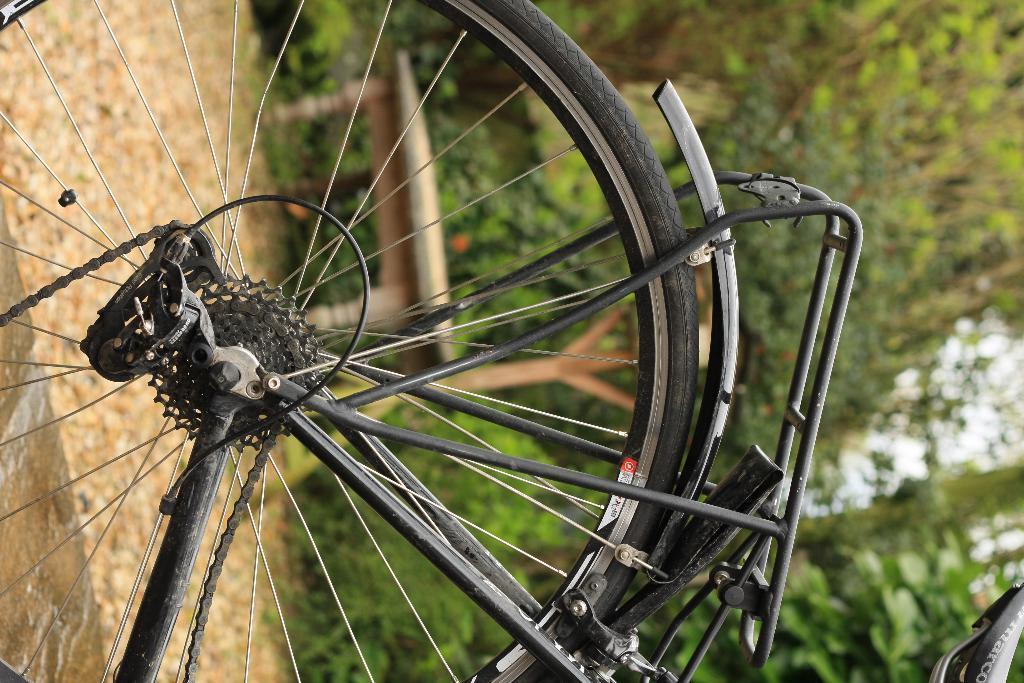How would you summarize this image in a sentence or two? In the picture we can see a bicycle back tire with rim, part of a chain, and on the tire, we can see a carrier and behind the bicycle we can see a table and behind it we can see full of plants and trees. 